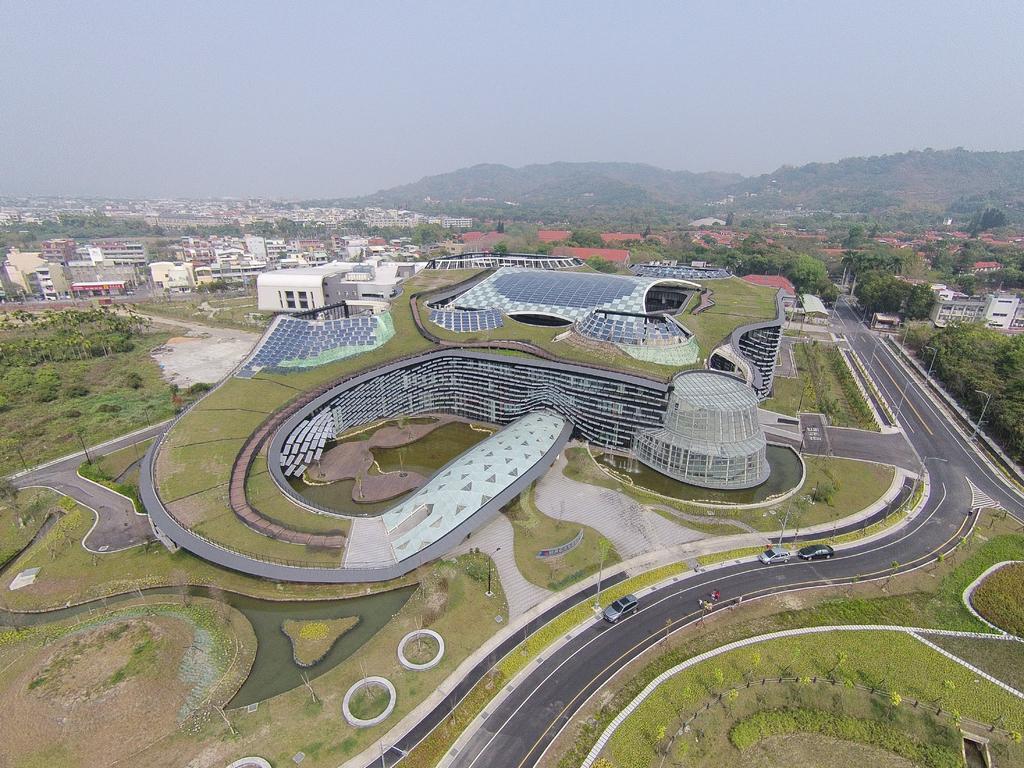Please provide a concise description of this image. This image is an aerial view. In this image there are many buildings and trees. We can see roads and there are vehicles on the roads. In the background there are hills and sky. 